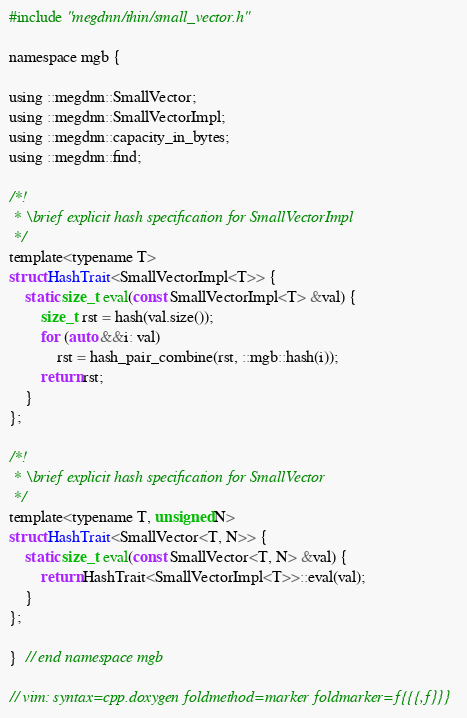<code> <loc_0><loc_0><loc_500><loc_500><_C_>#include "megdnn/thin/small_vector.h"

namespace mgb {

using ::megdnn::SmallVector;
using ::megdnn::SmallVectorImpl;
using ::megdnn::capacity_in_bytes;
using ::megdnn::find;

/*!
 * \brief explicit hash specification for SmallVectorImpl
 */
template<typename T>
struct HashTrait<SmallVectorImpl<T>> {
    static size_t eval(const SmallVectorImpl<T> &val) {
        size_t rst = hash(val.size());
        for (auto &&i: val)
            rst = hash_pair_combine(rst, ::mgb::hash(i));
        return rst;
    }
};

/*!
 * \brief explicit hash specification for SmallVector
 */
template<typename T, unsigned N>
struct HashTrait<SmallVector<T, N>> {
    static size_t eval(const SmallVector<T, N> &val) {
        return HashTrait<SmallVectorImpl<T>>::eval(val);
    }
};

}  // end namespace mgb

// vim: syntax=cpp.doxygen foldmethod=marker foldmarker=f{{{,f}}}
</code> 